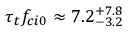<formula> <loc_0><loc_0><loc_500><loc_500>\tau _ { t } f _ { c i 0 } \approx 7 . 2 _ { - 3 . 2 } ^ { + 7 . 8 }</formula> 